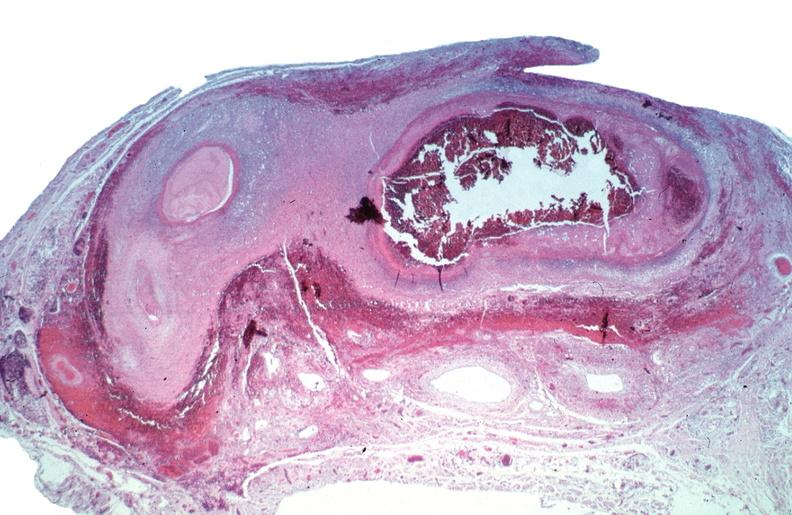where is this from?
Answer the question using a single word or phrase. Vasculature 